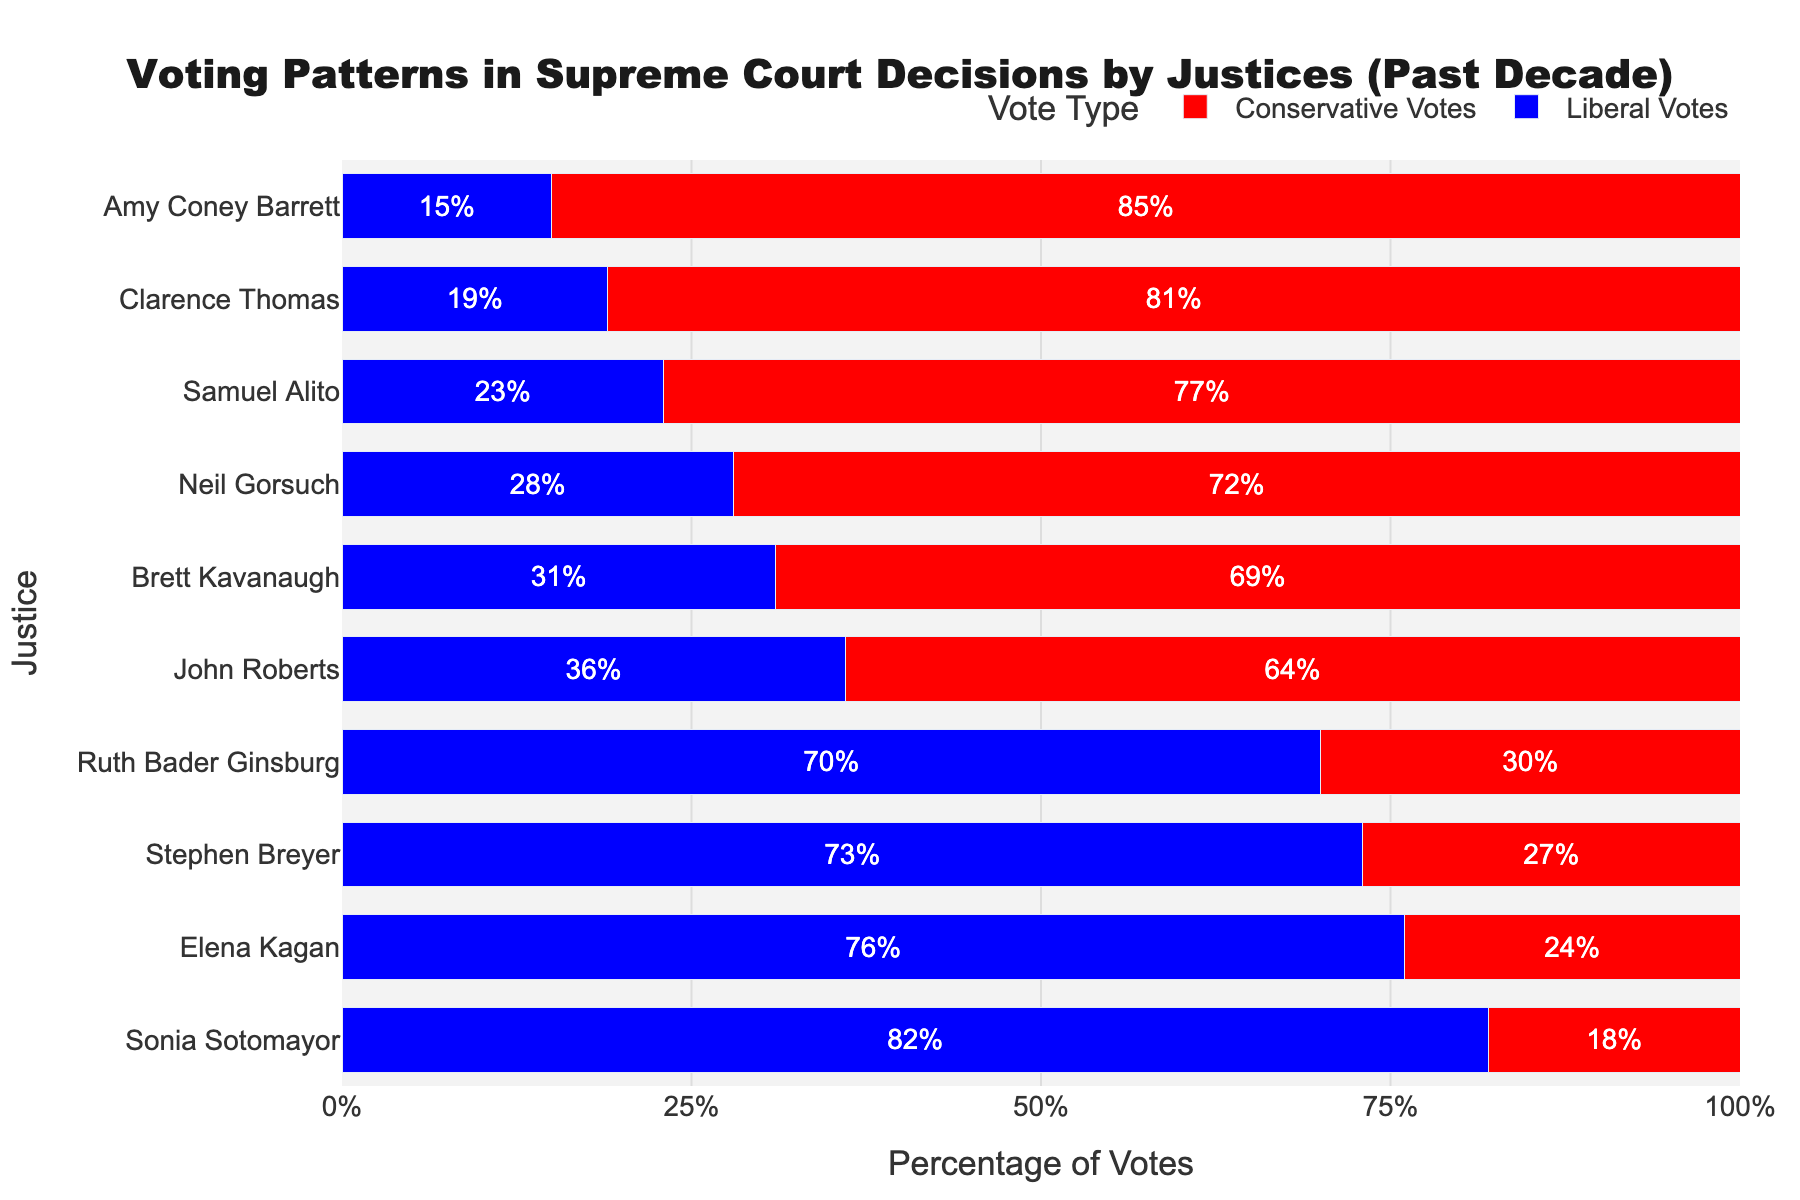How many conservative votes did Sonia Sotomayor cast? Sonia Sotomayor has 18% conservative votes. Since these are percentages, the answer is simply found by noting the value in the figure.
Answer: 18% Which justice had the highest percentage of liberal votes? By examining the figure, we can see that Sonia Sotomayor has the highest percentage of liberal votes, marked by the longest blue bar extending to 82%.
Answer: Sonia Sotomayor Among the justices with more than 50% liberal votes, who has the lowest percentage? We look at justices with bars extending more than halfway on the liberal votes side: Sotomayor (82%), Kagan (76%), Breyer (73%), and Ginsburg (70%). Ginsburg has the lowest percentage among them.
Answer: Ruth Bader Ginsburg What is the difference in liberal votes percentage between Elena Kagan and Amy Coney Barrett? Elena Kagan has 76% liberal votes while Amy Coney Barrett has 15%. The difference is calculated by subtracting 15 from 76.
Answer: 61% What is the average percentage of conservative votes given by John Roberts, Brett Kavanaugh, and Neil Gorsuch? John Roberts has 64%, Brett Kavanaugh has 69%, and Neil Gorsuch has 72% conservative votes. The average is calculated as (64 + 69 + 72) / 3.
Answer: 68.33% Who has a higher percentage of conservative votes, John Roberts or Clarence Thomas? Checking the figure, John Roberts has 64% conservative votes, whereas Clarence Thomas has 81%. Thus, Clarence Thomas has a higher percentage.
Answer: Clarence Thomas Which justice has a closer to equal balance of liberal and conservative votes? By observing the bars, John Roberts has the closest balance with 36% liberal and 64% conservative votes. Although these values aren't equal, they are the closest among all justices.
Answer: John Roberts How many justices have more than 50% conservative votes? By counting the bars extending more than halfway on the conservative votes side: Roberts, Kavanaugh, Gorsuch, Alito, Thomas, and Barrett. There are 6 justices.
Answer: 6 What is the total percentage sum of liberal votes from Sotomayor, Kagan, and Breyer? Add the respective liberal votes percentages: Sotomayor (82%), Kagan (76%), and Breyer (73%). The total is 82 + 76 + 73.
Answer: 231% What is the difference in conservative votes between the most conservative and the least conservative justice? The most conservative justice is Amy Coney Barrett with 85%, and the least is Sonia Sotomayor with 18%. The difference is 85 - 18.
Answer: 67% 